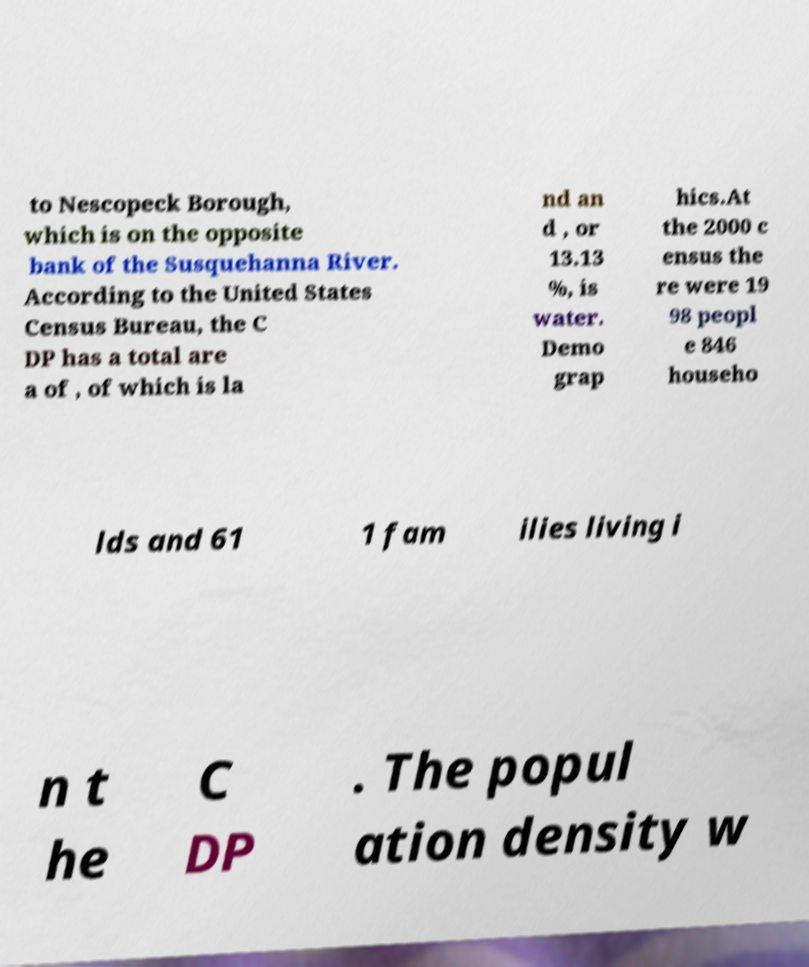Could you assist in decoding the text presented in this image and type it out clearly? to Nescopeck Borough, which is on the opposite bank of the Susquehanna River. According to the United States Census Bureau, the C DP has a total are a of , of which is la nd an d , or 13.13 %, is water. Demo grap hics.At the 2000 c ensus the re were 19 98 peopl e 846 househo lds and 61 1 fam ilies living i n t he C DP . The popul ation density w 